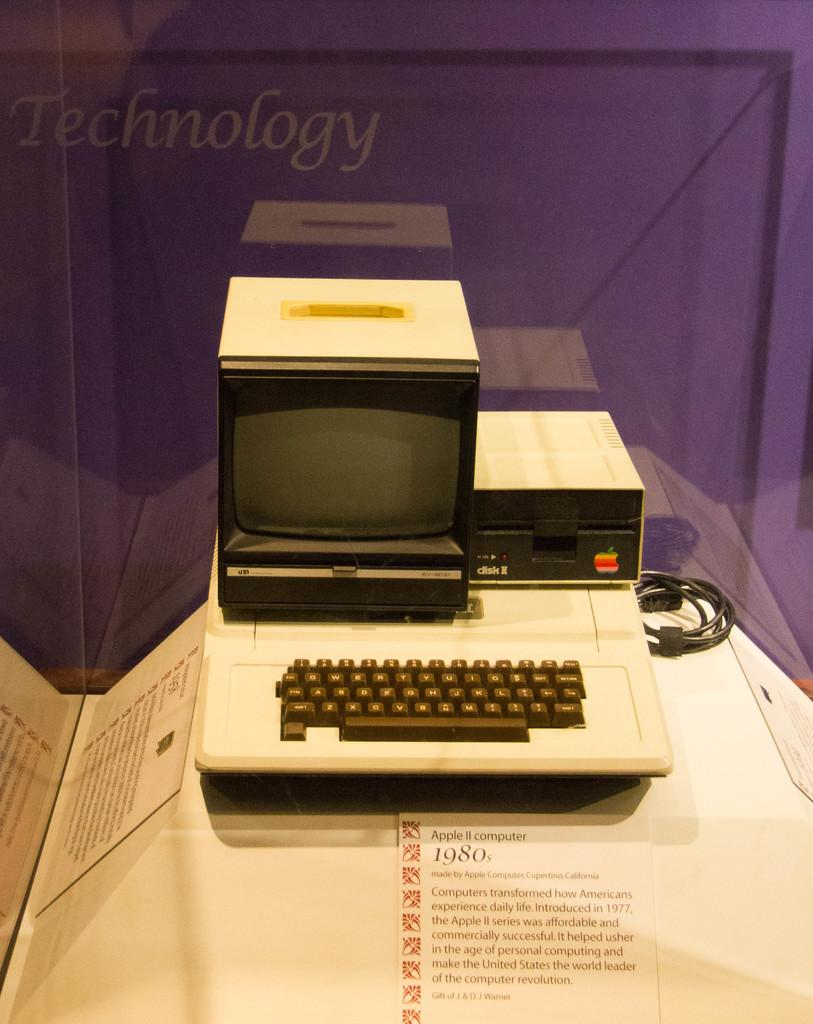<image>
Provide a brief description of the given image. display showing old apple II computer with floppy disk drive and monitor 